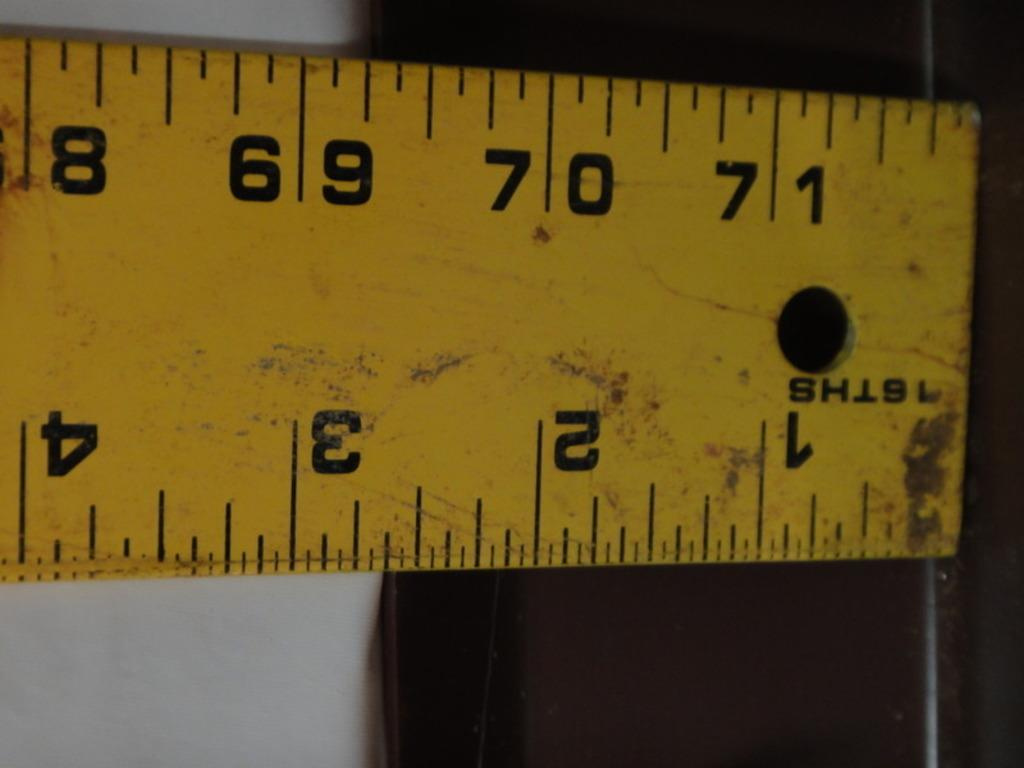<image>
Give a short and clear explanation of the subsequent image. a yellow ruler that measures in inches and centimeters. 